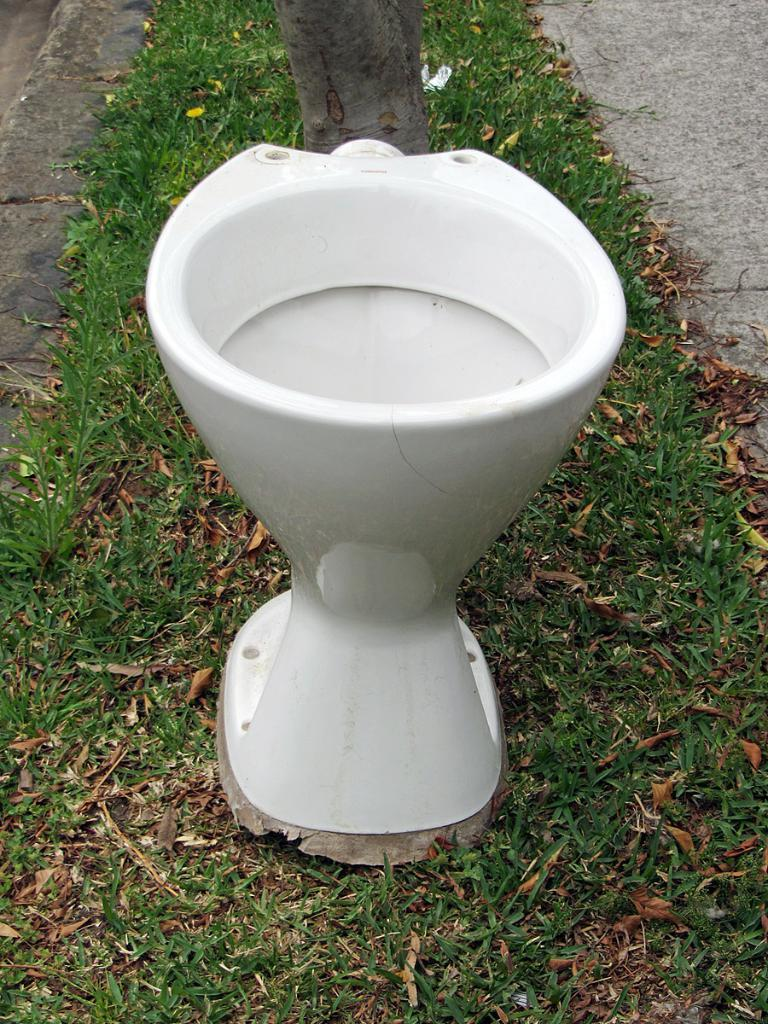What object is the main focus of the image? There is a toilet seat in the image. What type of natural environment is visible in the image? There is grass visible in the image. What additional objects can be seen in the image? There are dried leaves and a path in the image. What type of cemetery can be seen in the image? There is no cemetery present in the image; it features a toilet seat, grass, dried leaves, and a path. What type of hill is visible in the image? There is no hill visible in the image; it features a toilet seat, grass, dried leaves, and a path. 